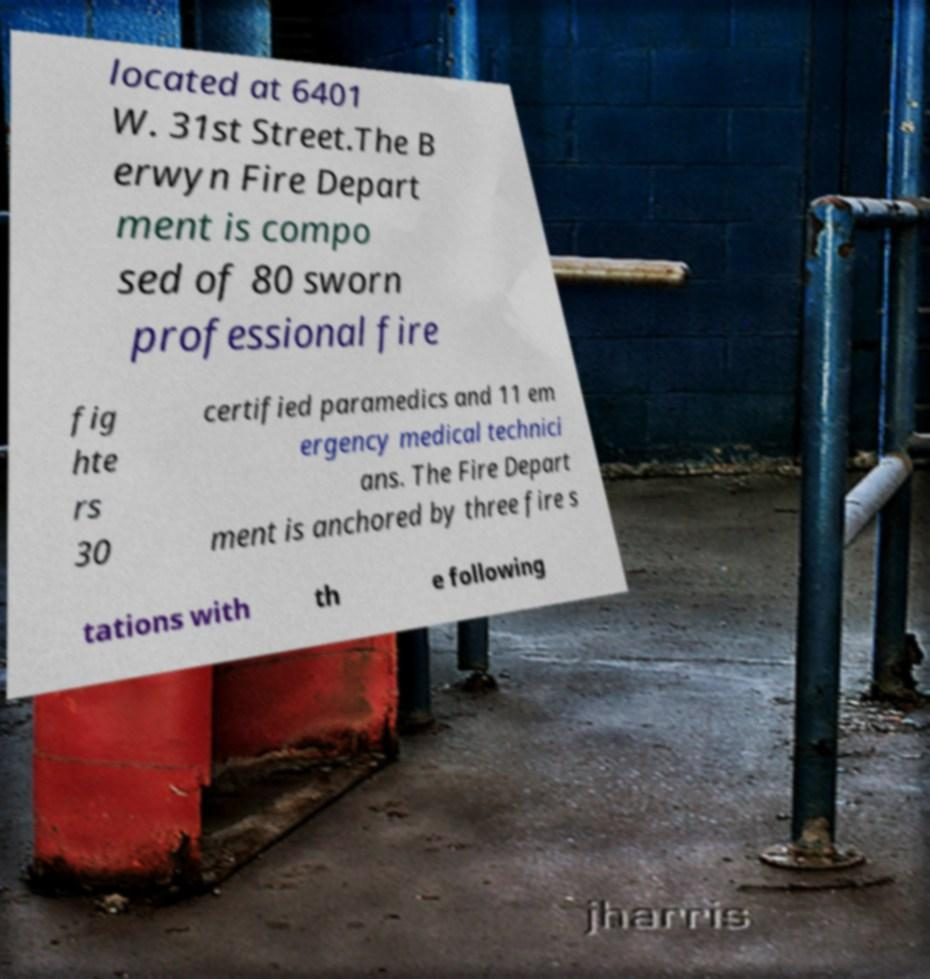Can you accurately transcribe the text from the provided image for me? located at 6401 W. 31st Street.The B erwyn Fire Depart ment is compo sed of 80 sworn professional fire fig hte rs 30 certified paramedics and 11 em ergency medical technici ans. The Fire Depart ment is anchored by three fire s tations with th e following 